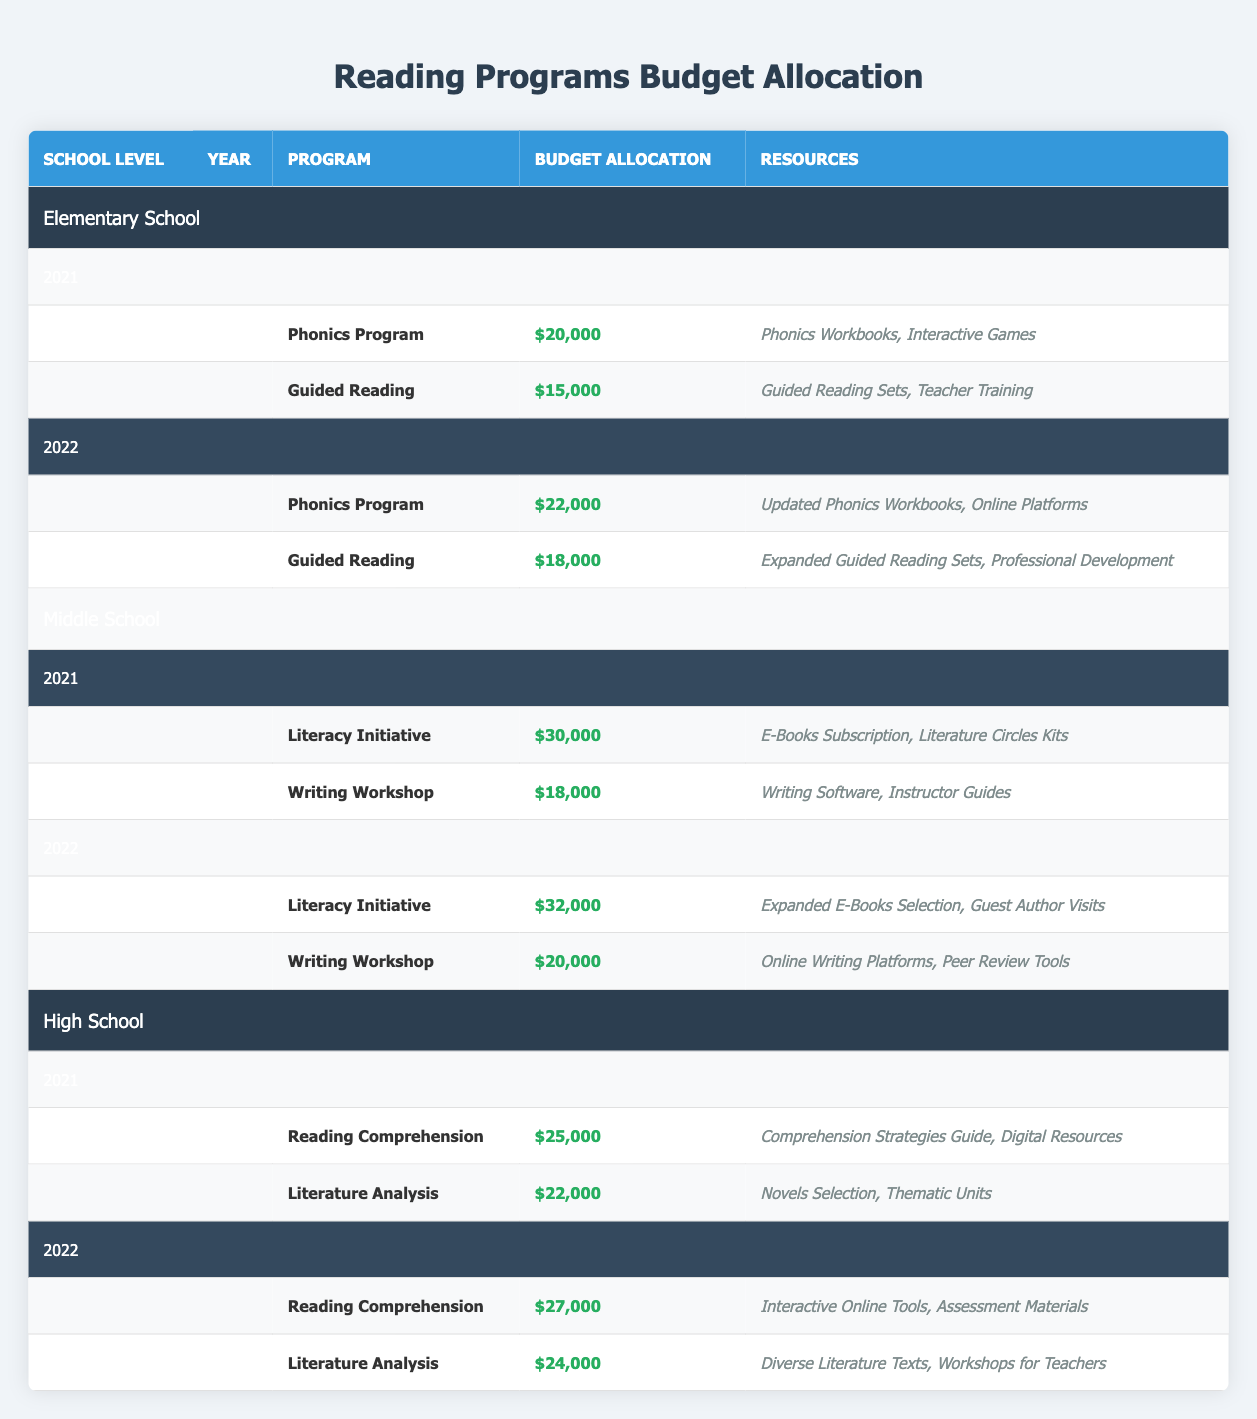What was the budget allocation for the Guided Reading program in 2021? The table shows that for the Guided Reading program in 2021, the budget allocation is presented directly in the row corresponding to that program. It states $15,000.
Answer: 15000 Which program received the highest budget allocation in Middle School for 2022? Looking at the Middle School section for 2022, the program with the highest budget allocation is the Literacy Initiative with a budget of $32,000, which is more than the $20,000 for Writing Workshop.
Answer: Literacy Initiative What is the total budget allocation for Reading Programs in High School across 2021? To find the total budget allocation in High School for 2021, I sum the allocations for both programs: Reading Comprehension ($25,000) and Literature Analysis ($22,000). The total is 25,000 + 22,000 = 47,000.
Answer: 47000 Did any program in Elementary School receive a budget allocation of more than $20,000 in 2021? Reviewing the budget allocations for Elementary School in 2021, neither the Phonics Program ($20,000) nor Guided Reading ($15,000) exceeds $20,000. Therefore, the answer is no.
Answer: No What was the average budget allocation for Writing Workshop between 2021 and 2022? The budget allocations for Writing Workshop are $18,000 in 2021 and $20,000 in 2022. To find the average, I add these amounts (18,000 + 20,000 = 38,000) and divide by 2, which results in 38,000 / 2 = 19,000.
Answer: 19000 Which program's budget allocation increased from 2021 to 2022 at the High School level? By examining the High School section for both years, Reading Comprehension increased from $25,000 in 2021 to $27,000 in 2022, while Literature Analysis also increased from $22,000 to $24,000. Therefore, both programs saw an increase.
Answer: Reading Comprehension and Literature Analysis Is it true that the budget allocation for Guided Reading was lower than that for Phonics Program in 2022? In 2022, the budget allocation for Guided Reading is $18,000, while for the Phonics Program, it is $22,000. Since 18,000 is less than 22,000, the statement is true.
Answer: Yes What is the difference in budget allocation between Literacy Initiative in 2022 and Literacy Initiative in 2021? The budget allocations for Literacy Initiative are $32,000 in 2022 and $30,000 in 2021. To find the difference, I subtract 30,000 from 32,000 to get 32,000 - 30,000 = 2,000.
Answer: 2000 What resources are included in the Writing Workshop for Middle School in 2022? The row for Writing Workshop in Middle School for 2022 lists two resources: "Online Writing Platforms" and "Peer Review Tools" directly in the resources column.
Answer: Online Writing Platforms, Peer Review Tools 